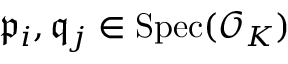<formula> <loc_0><loc_0><loc_500><loc_500>{ \mathfrak { p } } _ { i } , { \mathfrak { q } } _ { j } \in { S p e c } ( { \mathcal { O } } _ { K } )</formula> 